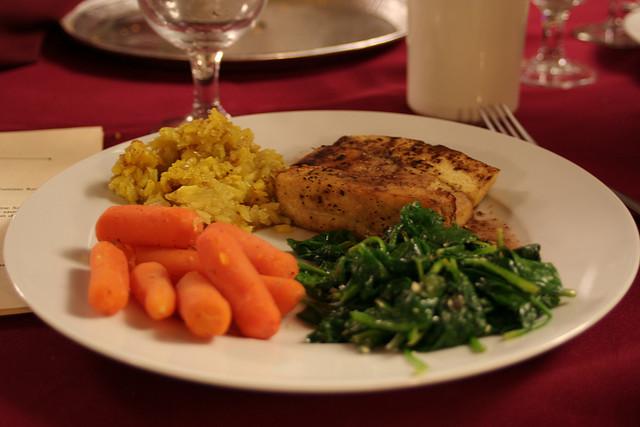Is this a desert?
Be succinct. No. Is this meal sweet?
Be succinct. No. Where the green vegetables wilted or steamed?
Quick response, please. Steamed. What type of wine is there?
Concise answer only. White. Are there any fruits on the plate?
Answer briefly. No. Is the wine glass empty?
Answer briefly. Yes. What kind of food is on the plate?
Concise answer only. Dinner. Do these foods nourish your body?
Be succinct. Yes. Is this a full meal?
Write a very short answer. Yes. What material is the tray?
Give a very brief answer. Plastic. Is the plate full?
Answer briefly. Yes. How many varieties of vegetables are there?
Keep it brief. 2. What is the green food on the plate?
Short answer required. Spinach. How many pancakes are there?
Write a very short answer. 0. Is that a healthy meal?
Short answer required. Yes. What meal is this?
Write a very short answer. Dinner. Where is the fork?
Quick response, please. Table. What vegetable is on the plate?
Write a very short answer. Carrots. What is the green vegetable?
Concise answer only. Spinach. Is this Chinese food?
Write a very short answer. No. 